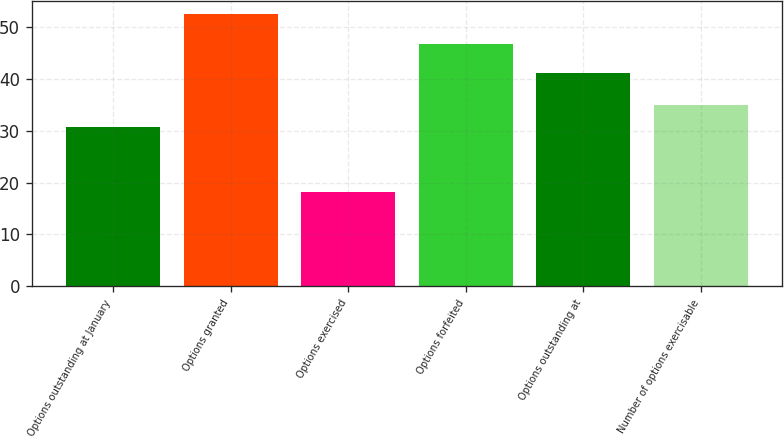Convert chart. <chart><loc_0><loc_0><loc_500><loc_500><bar_chart><fcel>Options outstanding at January<fcel>Options granted<fcel>Options exercised<fcel>Options forfeited<fcel>Options outstanding at<fcel>Number of options exercisable<nl><fcel>30.78<fcel>52.45<fcel>18.23<fcel>46.75<fcel>41.15<fcel>34.9<nl></chart> 